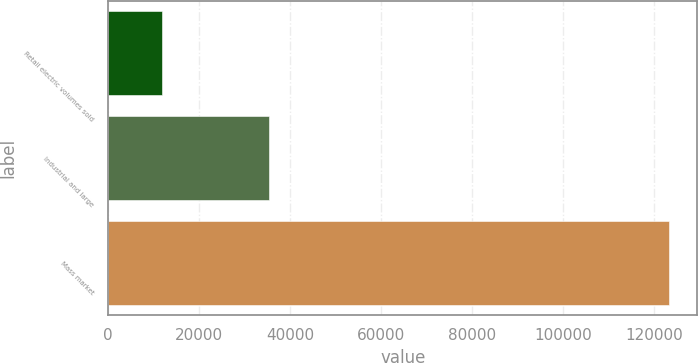<chart> <loc_0><loc_0><loc_500><loc_500><bar_chart><fcel>Retail electric volumes sold<fcel>Industrial and large<fcel>Mass market<nl><fcel>11871<fcel>35305<fcel>123314<nl></chart> 